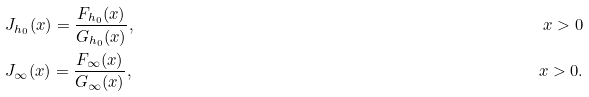<formula> <loc_0><loc_0><loc_500><loc_500>& J _ { h _ { 0 } } ( x ) = \frac { F _ { h _ { 0 } } ( x ) } { G _ { h _ { 0 } } ( x ) } , & x > 0 \\ & J _ { \infty } ( x ) = \frac { F _ { \infty } ( x ) } { G _ { \infty } ( x ) } , & x > 0 .</formula> 